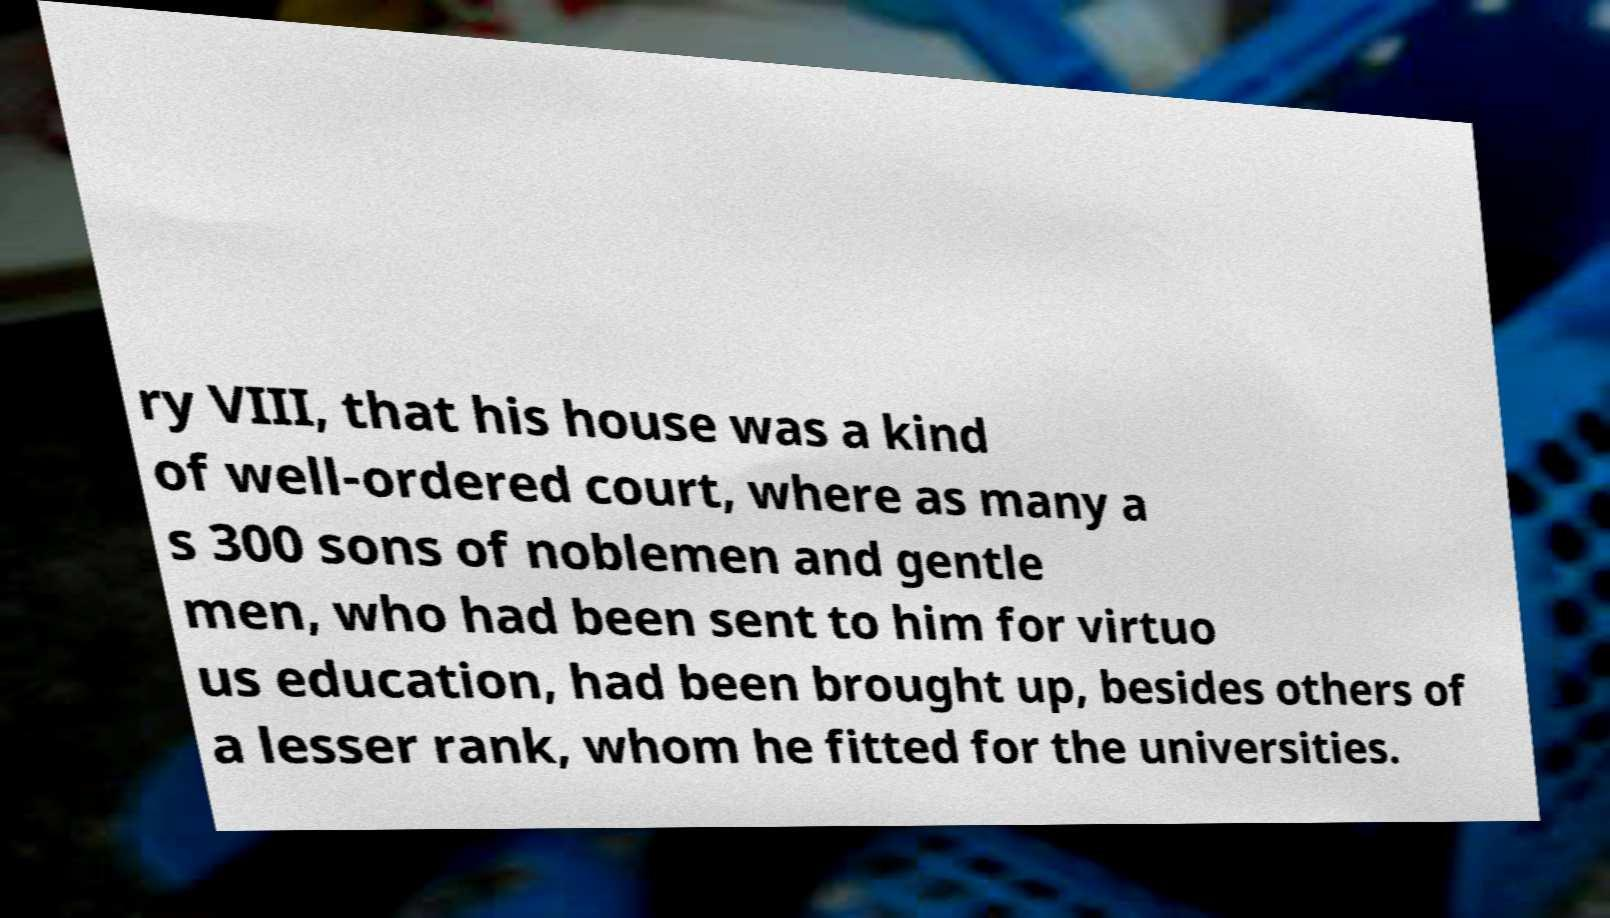For documentation purposes, I need the text within this image transcribed. Could you provide that? ry VIII, that his house was a kind of well-ordered court, where as many a s 300 sons of noblemen and gentle men, who had been sent to him for virtuo us education, had been brought up, besides others of a lesser rank, whom he fitted for the universities. 